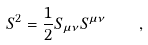Convert formula to latex. <formula><loc_0><loc_0><loc_500><loc_500>S ^ { 2 } = \frac { 1 } { 2 } S _ { \mu \nu } S ^ { \mu \nu } \quad ,</formula> 